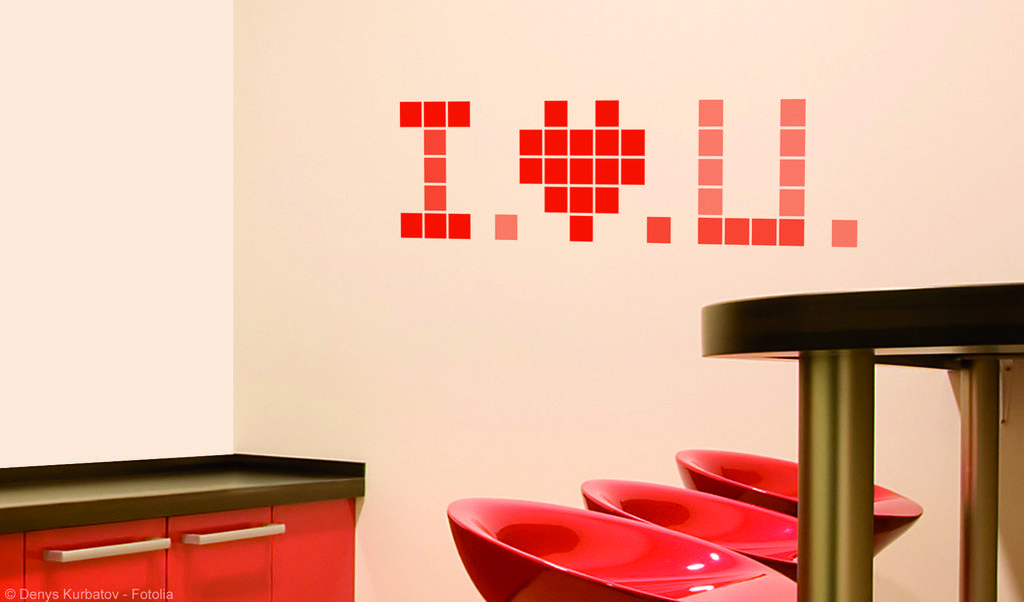What type of furniture is visible in the image? There are chairs and a table in the image. Is there any storage furniture in the image? Yes, there is a cupboard in the image. Where is the cupboard located in the image? The cupboard is on the back, presumably the back of the room or area. What color is the wall in the image? The wall in the image is white. What is written on the white wall? There is red color text on the white wall. What type of scent can be detected from the earth in the image? There is no reference to earth or scent in the image, so it is not possible to answer that question. 